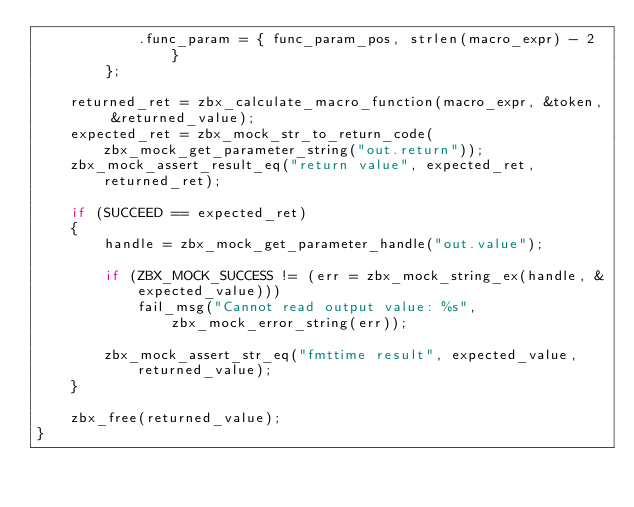Convert code to text. <code><loc_0><loc_0><loc_500><loc_500><_C_>			.func_param	= { func_param_pos, strlen(macro_expr) - 2 }
		};

	returned_ret = zbx_calculate_macro_function(macro_expr, &token, &returned_value);
	expected_ret = zbx_mock_str_to_return_code(zbx_mock_get_parameter_string("out.return"));
	zbx_mock_assert_result_eq("return value", expected_ret, returned_ret);

	if (SUCCEED == expected_ret)
	{
		handle = zbx_mock_get_parameter_handle("out.value");

		if (ZBX_MOCK_SUCCESS != (err = zbx_mock_string_ex(handle, &expected_value)))
			fail_msg("Cannot read output value: %s", zbx_mock_error_string(err));

		zbx_mock_assert_str_eq("fmttime result", expected_value, returned_value);
	}

	zbx_free(returned_value);
}
</code> 